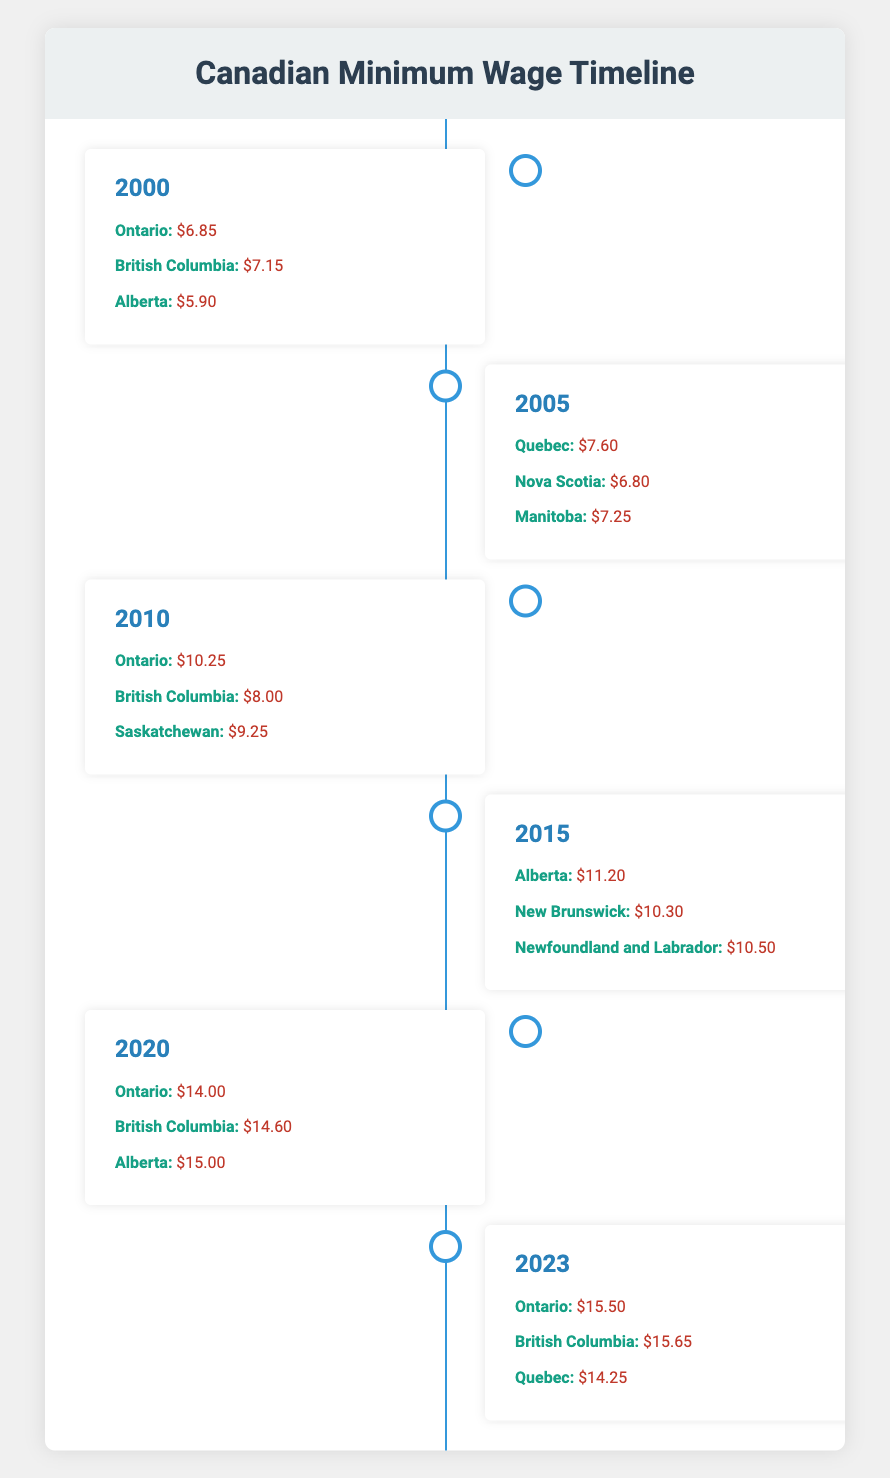What was the minimum wage in Ontario in 2000? The table indicates that in 2000, Ontario's minimum wage was $6.85.
Answer: $6.85 Which province had the highest minimum wage in 2015? In 2015, Alberta had the highest minimum wage at $11.20, as compared to the other provinces listed for that year.
Answer: $11.20 What is the average minimum wage across all provinces listed for 2020? For 2020, the minimum wages are $14.00 (Ontario), $14.60 (British Columbia), and $15.00 (Alberta). The total is $14.00 + $14.60 + $15.00 = $43.60. There are three provinces, so the average is $43.60 / 3 = $14.53.
Answer: $14.53 Did Quebec increase its minimum wage from 2010 to 2023? In 2010, Quebec's minimum wage was not listed, but in 2023 it is $14.25. Since the wage for 2010 is unknown, we cannot determine if it increased.
Answer: No Which province had the lowest minimum wage in 2000 and what was it? According to the table, Alberta had the lowest minimum wage in 2000 at $5.90, making it the province with the lowest value for that year.
Answer: $5.90 Calculate the difference in minimum wage between the highest and lowest values in 2023. In 2023, the highest minimum wage is $15.65 (British Columbia) and the lowest is $14.25 (Quebec). The difference is $15.65 - $14.25 = $1.40.
Answer: $1.40 Is the minimum wage in British Columbia higher than the minimum wage in Ontario in 2023? In 2023, British Columbia's minimum wage is $15.65, while Ontario's is $15.50. Since $15.65 is more than $15.50, this statement is true.
Answer: Yes Which province had a minimum wage of $10.30 in 2015? The table shows that New Brunswick had a minimum wage of $10.30 in 2015, making it the only province listed for that wage.
Answer: New Brunswick 